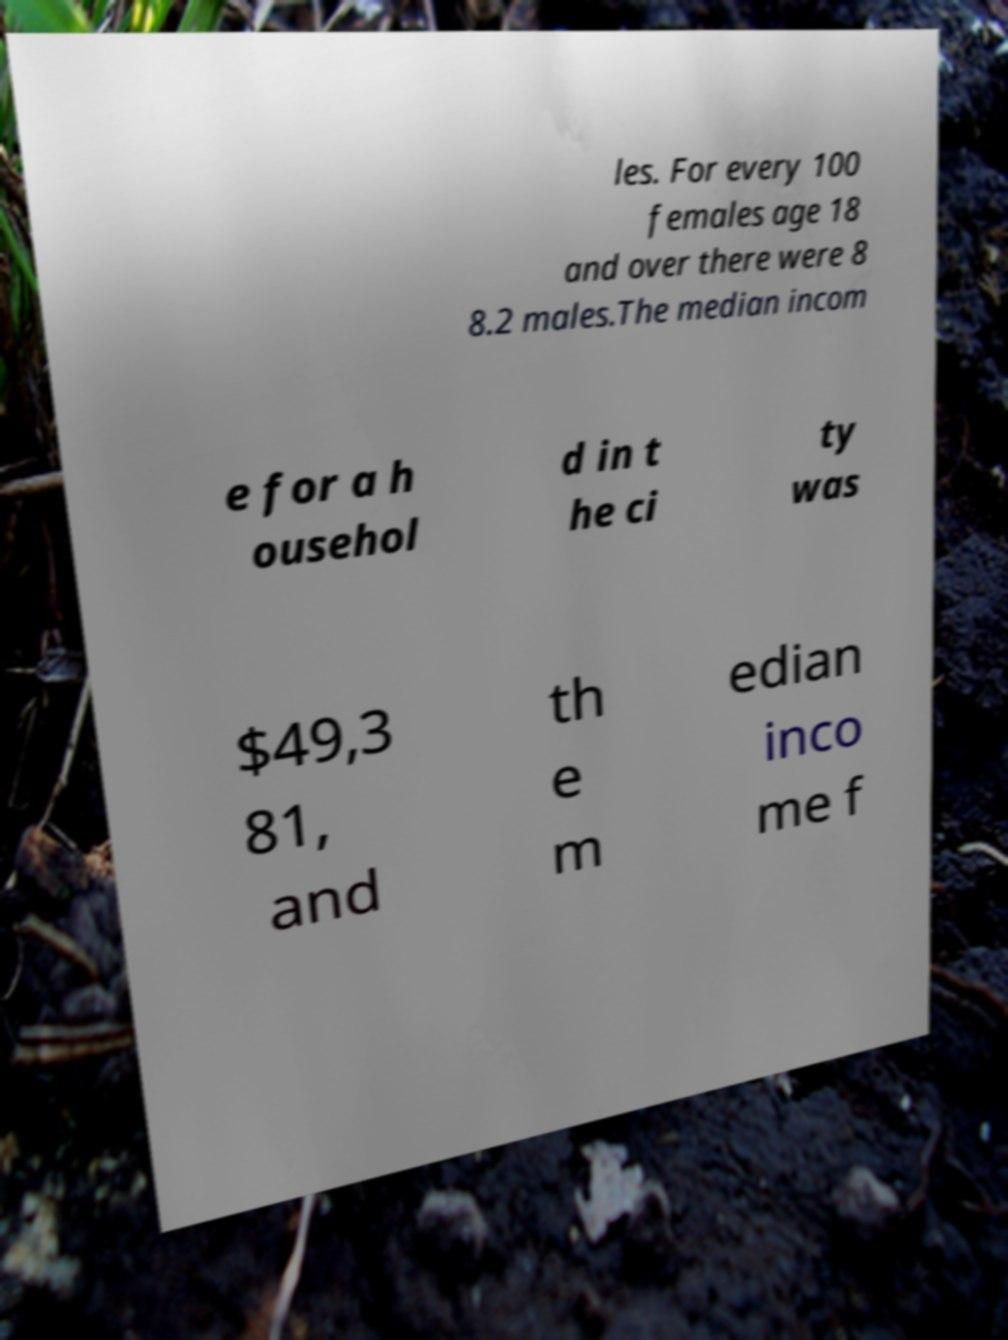Could you assist in decoding the text presented in this image and type it out clearly? les. For every 100 females age 18 and over there were 8 8.2 males.The median incom e for a h ousehol d in t he ci ty was $49,3 81, and th e m edian inco me f 